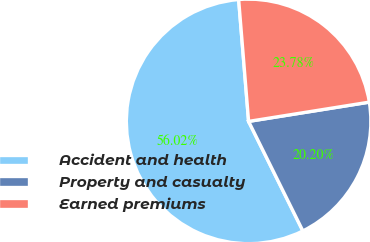Convert chart. <chart><loc_0><loc_0><loc_500><loc_500><pie_chart><fcel>Accident and health<fcel>Property and casualty<fcel>Earned premiums<nl><fcel>56.03%<fcel>20.2%<fcel>23.78%<nl></chart> 